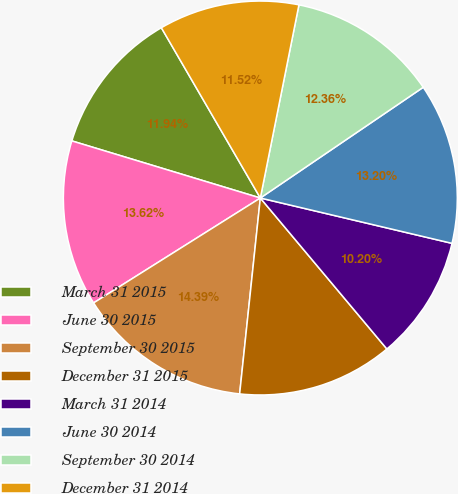<chart> <loc_0><loc_0><loc_500><loc_500><pie_chart><fcel>March 31 2015<fcel>June 30 2015<fcel>September 30 2015<fcel>December 31 2015<fcel>March 31 2014<fcel>June 30 2014<fcel>September 30 2014<fcel>December 31 2014<nl><fcel>11.94%<fcel>13.62%<fcel>14.39%<fcel>12.78%<fcel>10.2%<fcel>13.2%<fcel>12.36%<fcel>11.52%<nl></chart> 